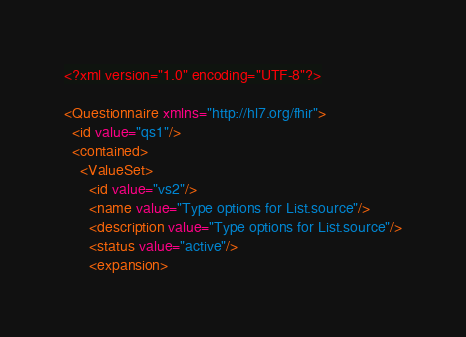Convert code to text. <code><loc_0><loc_0><loc_500><loc_500><_XML_><?xml version="1.0" encoding="UTF-8"?>

<Questionnaire xmlns="http://hl7.org/fhir">
  <id value="qs1"/>
  <contained>
    <ValueSet>
      <id value="vs2"/>
      <name value="Type options for List.source"/>
      <description value="Type options for List.source"/>
      <status value="active"/>
      <expansion></code> 